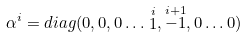<formula> <loc_0><loc_0><loc_500><loc_500>\alpha ^ { i } = d i a g ( 0 , 0 , 0 \dots \stackrel { i } { 1 } , \stackrel { i + 1 } { - 1 } , 0 \dots 0 )</formula> 